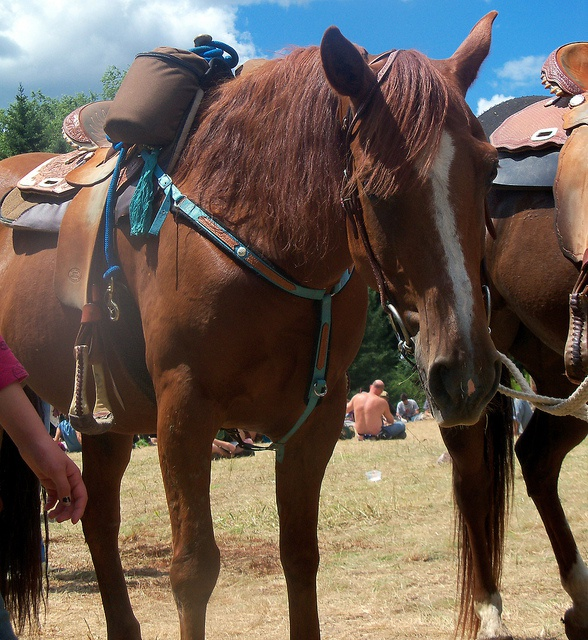Describe the objects in this image and their specific colors. I can see horse in white, black, maroon, brown, and gray tones, horse in white, black, maroon, and tan tones, people in white, maroon, brown, and black tones, people in white, brown, salmon, gray, and black tones, and people in white, black, brown, and maroon tones in this image. 